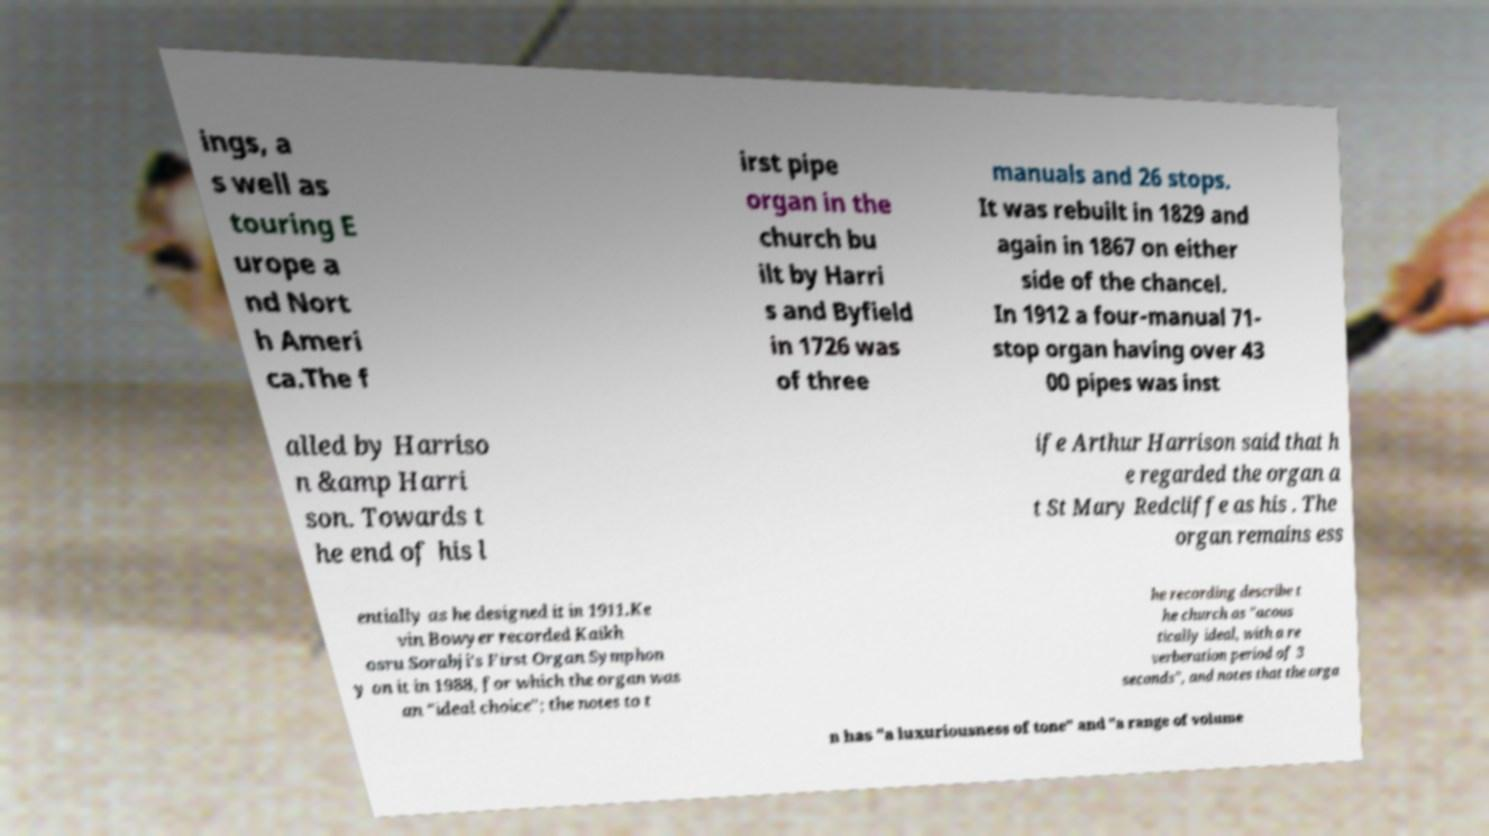What messages or text are displayed in this image? I need them in a readable, typed format. ings, a s well as touring E urope a nd Nort h Ameri ca.The f irst pipe organ in the church bu ilt by Harri s and Byfield in 1726 was of three manuals and 26 stops. It was rebuilt in 1829 and again in 1867 on either side of the chancel. In 1912 a four-manual 71- stop organ having over 43 00 pipes was inst alled by Harriso n &amp Harri son. Towards t he end of his l ife Arthur Harrison said that h e regarded the organ a t St Mary Redcliffe as his . The organ remains ess entially as he designed it in 1911.Ke vin Bowyer recorded Kaikh osru Sorabji's First Organ Symphon y on it in 1988, for which the organ was an "ideal choice"; the notes to t he recording describe t he church as "acous tically ideal, with a re verberation period of 3 seconds", and notes that the orga n has "a luxuriousness of tone" and "a range of volume 